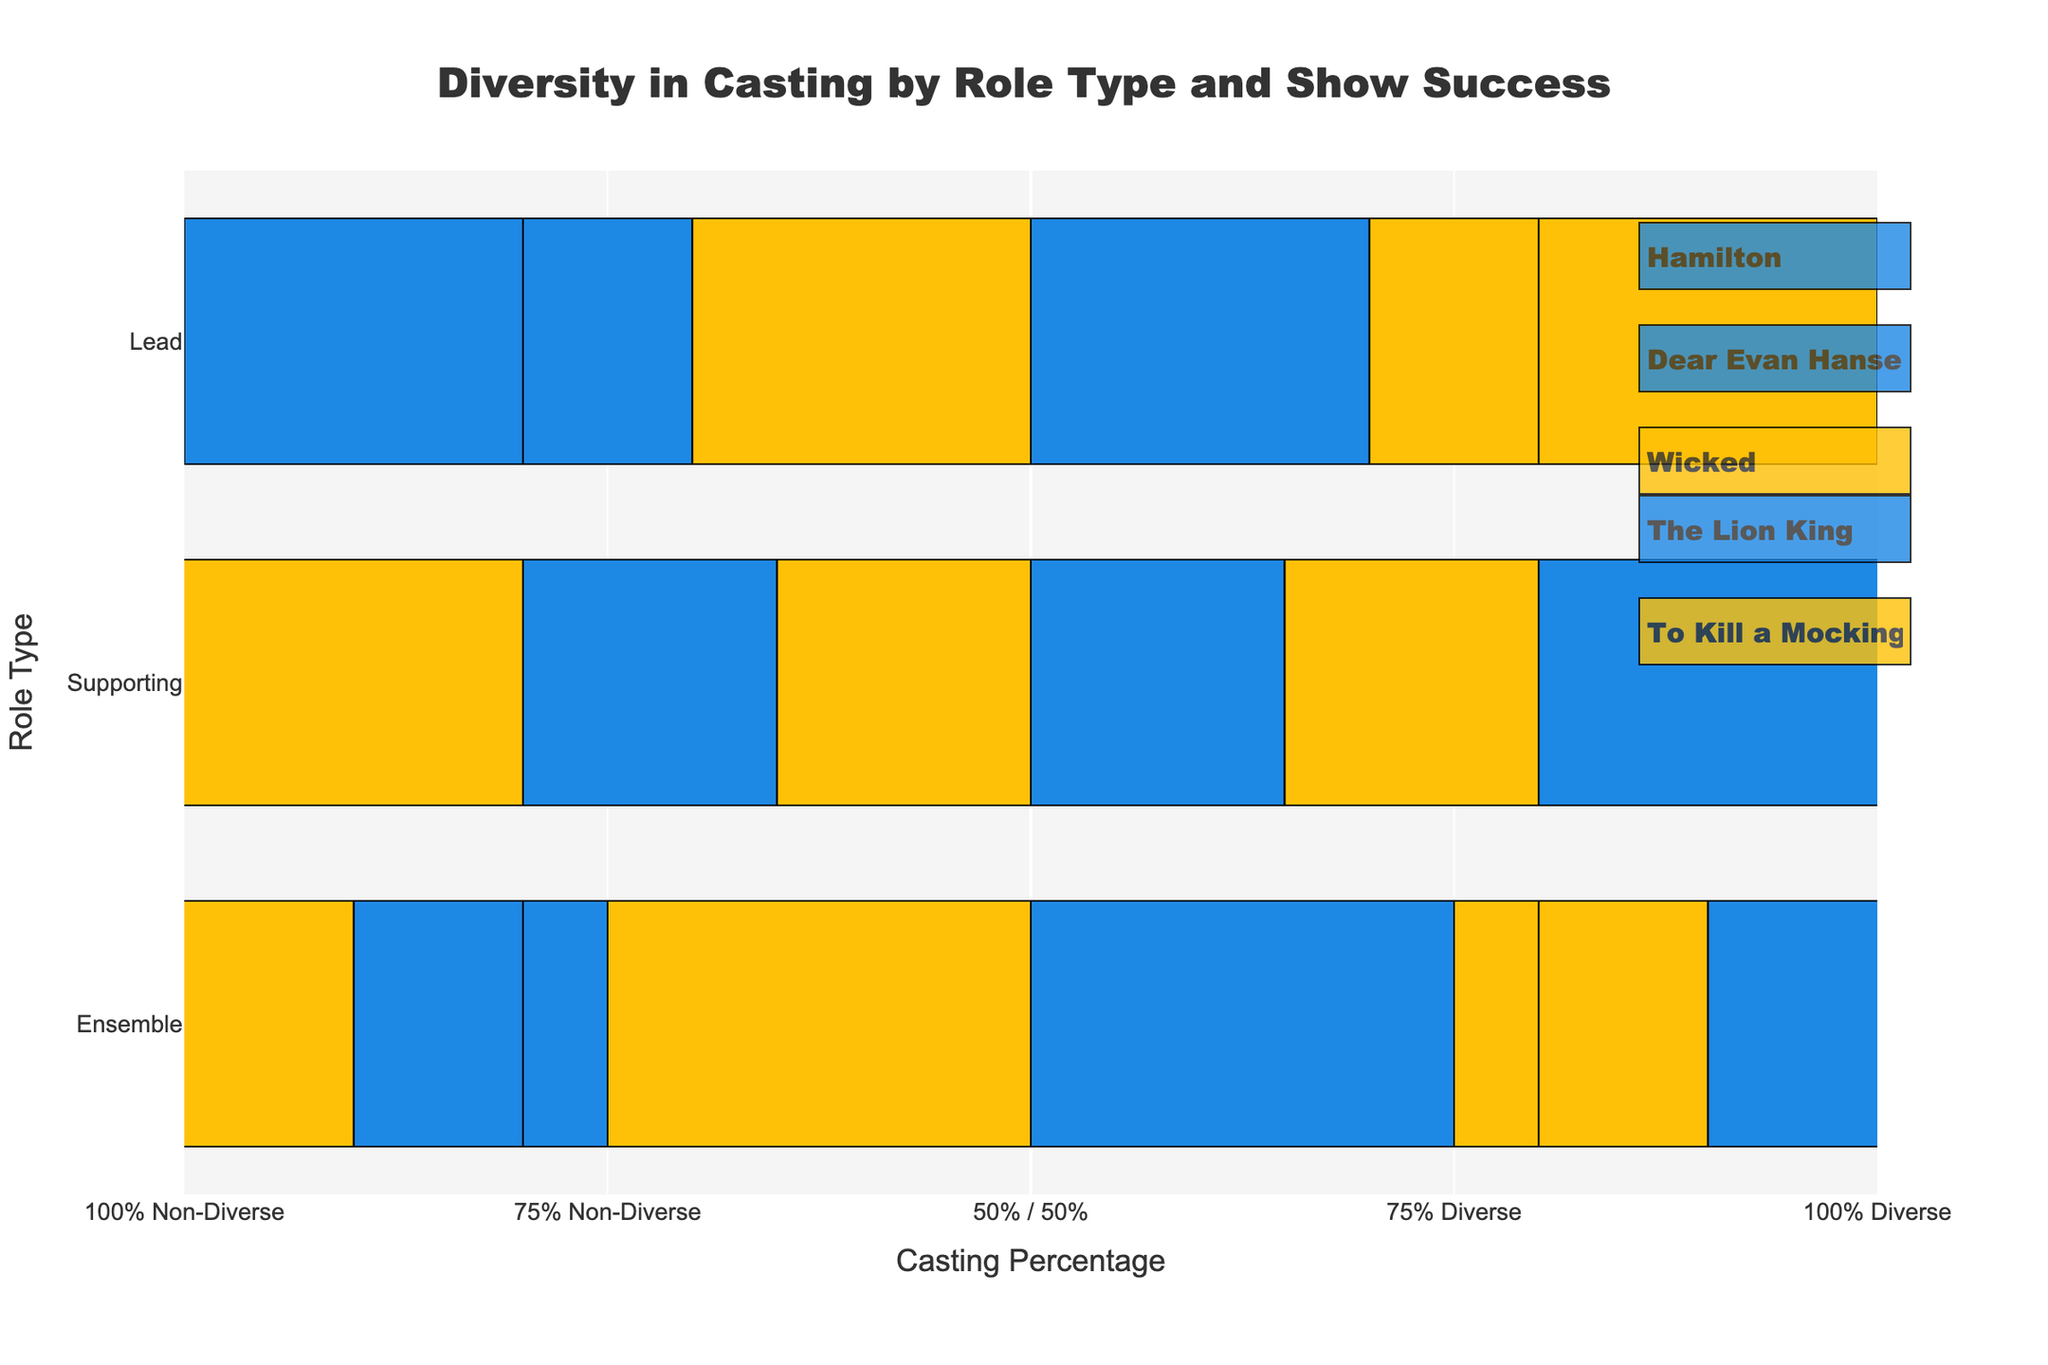Who had the most diverse lead casting, Hamilton or The Lion King? The lead casting of Hamilton was 70% diverse, whereas The Lion King was 80% diverse. Comparing these figures shows that The Lion King had a more diverse lead casting.
Answer: The Lion King How much more diverse was the supporting role casting of Hamilton compared to Wicked? Hamilton had 65% diverse casting in supporting roles, while Wicked had 35%. The difference is 65% - 35% = 30%.
Answer: 30% Which show had a higher proportion of ensemble roles casted non-diverse, Dear Evan Hansen or To Kill a Mockingbird? Dear Evan Hansen had 55% non-diverse ensemble casting, and To Kill a Mockingbird had 40% non-diverse ensemble casting. Comparing these values shows that Dear Evan Hansen had a higher proportion.
Answer: Dear Evan Hansen What is the average percentage of diverse casting for both lead and supporting roles in To Kill a Mockingbird? The lead role in To Kill a Mockingbird had 50% diverse casting, and the supporting role had 55% diverse casting. The average is (50 + 55) / 2 = 52.5%.
Answer: 52.5% Which show had the least diverse supporting roles casting, and what percentage was it? The least diverse supporting role casting was in Wicked, with 35%.
Answer: Wicked, 35% Among all the shows categorized as successes, which had the highest percentage of diverse ensemble casting? Hamilton had 75%, Dear Evan Hansen had 45%, and The Lion King had 90% diverse ensemble casting. Comparing these, The Lion King had the highest percentage.
Answer: The Lion King Compare the non-diverse casting percentages of leads in Dear Evan Hansen and Wicked. Dear Evan Hansen had a 60% non-diverse lead casting, and Wicked had 70%. Therefore, Wicked had a higher non-diverse casting percentage for leads.
Answer: Wicked What is the difference in diverse casting between the ensemble and lead roles in The Lion King? The Lion King had 90% diverse casting in ensemble roles and 80% in lead roles. The difference is 90% - 80% = 10%.
Answer: 10% Considering all success and moderate success shows, which one had the most balanced (50/50) diverse and non-diverse casting in any role type? To Kill a Mockingbird had an exact 50/50 (diverse/non-diverse) casting in lead roles and Dear Evan Hansen had an exact 50/50 (diverse/non-diverse) casting in supporting roles.
Answer: To Kill a Mockingbird, Dear Evan Hansen 